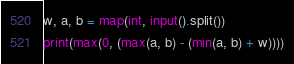Convert code to text. <code><loc_0><loc_0><loc_500><loc_500><_Python_>w, a, b = map(int, input().split())
print(max(0, (max(a, b) - (min(a, b) + w))))</code> 